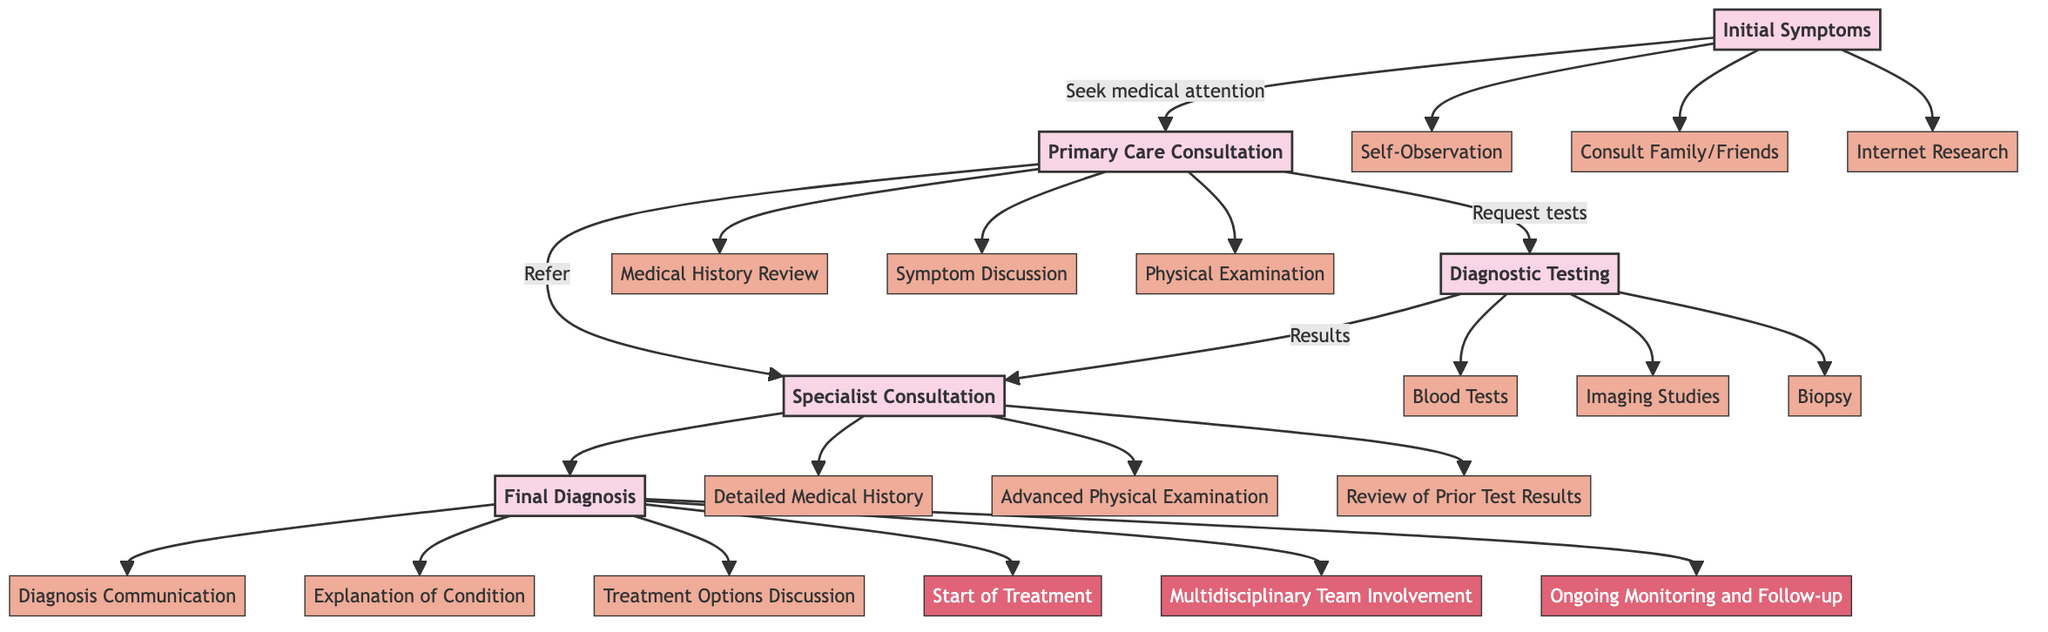What is the first step in the patient diagnosis journey? The first step is labeled as "Initial Symptoms" in the diagram, which indicates when a patient experiences symptoms that prompt them to seek medical attention.
Answer: Initial Symptoms How many actions are associated with the "Primary Care Consultation" step? The "Primary Care Consultation" step is connected to three actions: Medical History Review, Symptom Discussion, and Physical Examination, as represented in the diagram.
Answer: 3 What is one possible outcome after "Diagnostic Testing"? One possible outcome shown after "Diagnostic Testing" in the diagram is "Confirmation of Initial Diagnosis," indicating that the test results may confirm what was initially thought.
Answer: Confirmation of Initial Diagnosis Which step leads directly to "Final Diagnosis"? "Specialist Consultation" is the step that directly precedes "Final Diagnosis," as shown in the flow of the diagram indicating the direction of the process.
Answer: Specialist Consultation List the actions taken during the "Final Diagnosis" step. The actions indicated during the "Final Diagnosis" step are Diagnosis Communication, Explanation of Condition, and Treatment Options Discussion, which detail how the diagnosis is conveyed to the patient.
Answer: Diagnosis Communication, Explanation of Condition, Treatment Options Discussion What is the total number of steps in the patient diagnosis journey? The diagram depicts five distinct steps in the patient diagnosis journey, from Initial Symptoms to Final Diagnosis, marking the full process the patient undergoes.
Answer: 5 What leads to the action of requesting additional tests? The action of requesting additional tests comes after the "Specialist Consultation" step when a specialist makes a recommendation for additional tests based on their examination and review of prior test results.
Answer: Recommendation for Additional Tests Which action occurs after the "Initial Symptoms" step? Following the "Initial Symptoms" step, the next step where the patient's experience transitions is to "Primary Care Consultation," where they seek professional medical advice.
Answer: Primary Care Consultation What is the last possible outcome after "Final Diagnosis"? One of the last possible outcomes after "Final Diagnosis" is "Ongoing Monitoring and Follow-up," indicating that the patient's condition will need continuous attention.
Answer: Ongoing Monitoring and Follow-up 